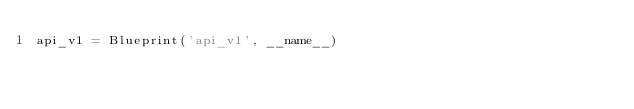<code> <loc_0><loc_0><loc_500><loc_500><_Python_>api_v1 = Blueprint('api_v1', __name__)</code> 